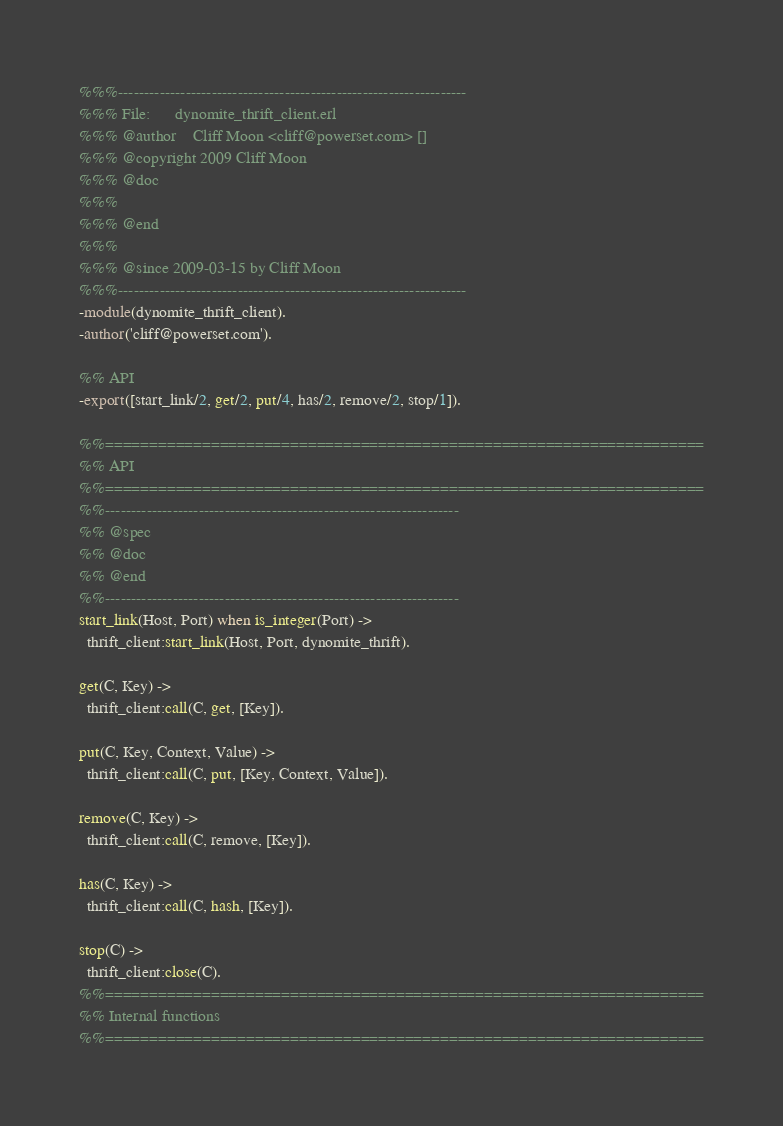<code> <loc_0><loc_0><loc_500><loc_500><_Erlang_>%%%-------------------------------------------------------------------
%%% File:      dynomite_thrift_client.erl
%%% @author    Cliff Moon <cliff@powerset.com> []
%%% @copyright 2009 Cliff Moon
%%% @doc  
%%%
%%% @end  
%%%
%%% @since 2009-03-15 by Cliff Moon
%%%-------------------------------------------------------------------
-module(dynomite_thrift_client).
-author('cliff@powerset.com').

%% API
-export([start_link/2, get/2, put/4, has/2, remove/2, stop/1]).

%%====================================================================
%% API
%%====================================================================
%%--------------------------------------------------------------------
%% @spec 
%% @doc
%% @end 
%%--------------------------------------------------------------------
start_link(Host, Port) when is_integer(Port) ->
  thrift_client:start_link(Host, Port, dynomite_thrift).
  
get(C, Key) ->
  thrift_client:call(C, get, [Key]).
  
put(C, Key, Context, Value) ->
  thrift_client:call(C, put, [Key, Context, Value]).
  
remove(C, Key) ->
  thrift_client:call(C, remove, [Key]).
  
has(C, Key) ->
  thrift_client:call(C, hash, [Key]).

stop(C) ->
  thrift_client:close(C).
%%====================================================================
%% Internal functions
%%====================================================================

</code> 